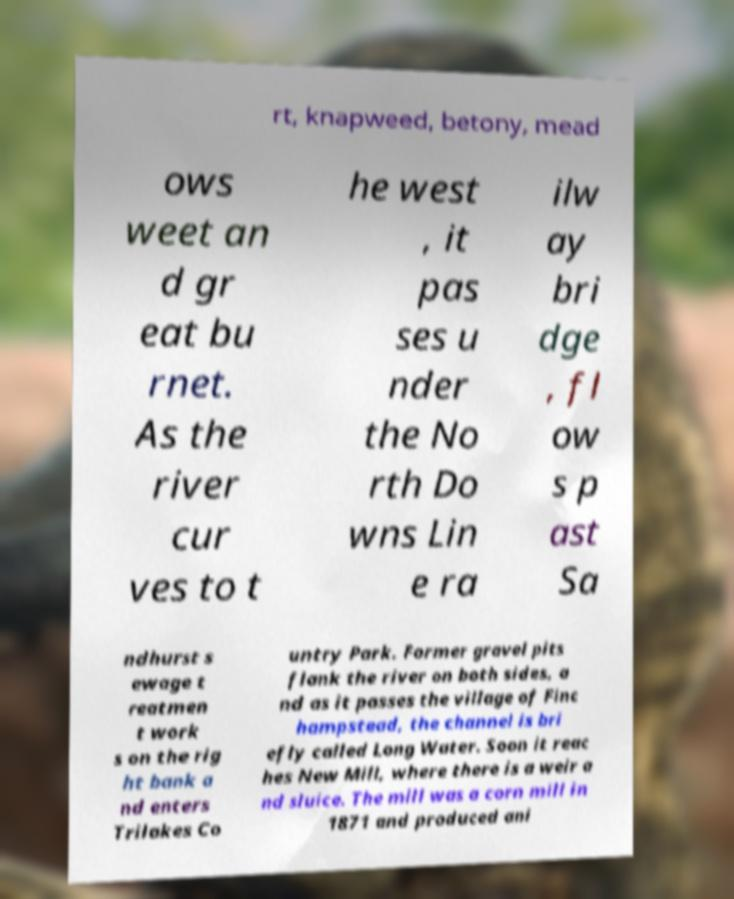Please identify and transcribe the text found in this image. rt, knapweed, betony, mead ows weet an d gr eat bu rnet. As the river cur ves to t he west , it pas ses u nder the No rth Do wns Lin e ra ilw ay bri dge , fl ow s p ast Sa ndhurst s ewage t reatmen t work s on the rig ht bank a nd enters Trilakes Co untry Park. Former gravel pits flank the river on both sides, a nd as it passes the village of Finc hampstead, the channel is bri efly called Long Water. Soon it reac hes New Mill, where there is a weir a nd sluice. The mill was a corn mill in 1871 and produced ani 